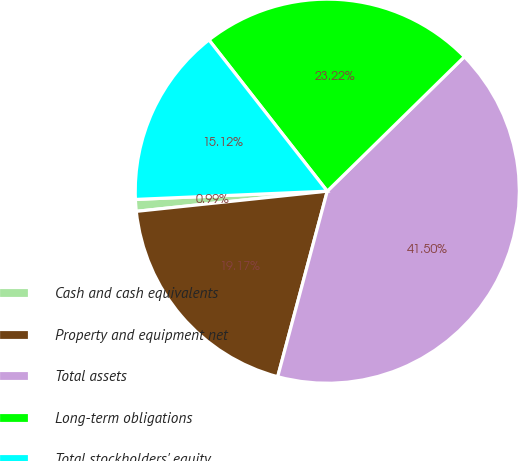Convert chart. <chart><loc_0><loc_0><loc_500><loc_500><pie_chart><fcel>Cash and cash equivalents<fcel>Property and equipment net<fcel>Total assets<fcel>Long-term obligations<fcel>Total stockholders' equity<nl><fcel>0.99%<fcel>19.17%<fcel>41.5%<fcel>23.22%<fcel>15.12%<nl></chart> 